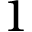Convert formula to latex. <formula><loc_0><loc_0><loc_500><loc_500>1</formula> 